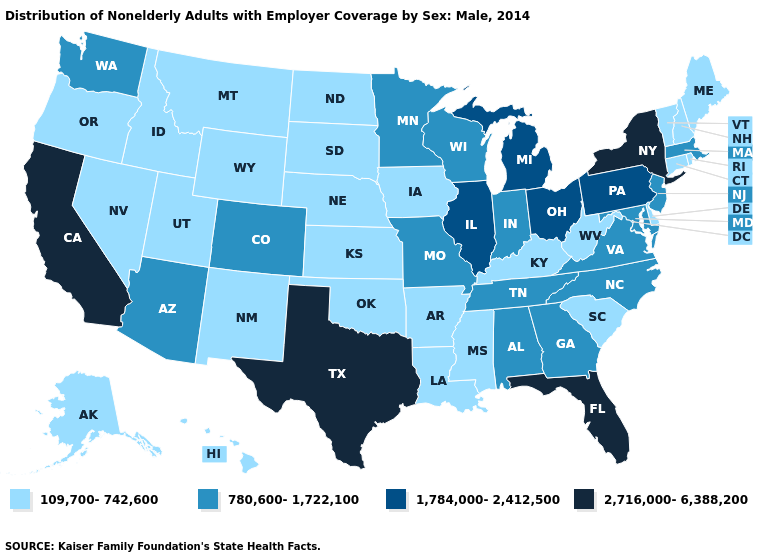What is the highest value in the MidWest ?
Be succinct. 1,784,000-2,412,500. Does the map have missing data?
Quick response, please. No. Does Virginia have a higher value than South Dakota?
Be succinct. Yes. Name the states that have a value in the range 1,784,000-2,412,500?
Answer briefly. Illinois, Michigan, Ohio, Pennsylvania. Among the states that border Ohio , which have the highest value?
Give a very brief answer. Michigan, Pennsylvania. What is the highest value in the MidWest ?
Short answer required. 1,784,000-2,412,500. Among the states that border Vermont , does New York have the lowest value?
Give a very brief answer. No. What is the lowest value in the USA?
Write a very short answer. 109,700-742,600. Does the map have missing data?
Quick response, please. No. Does the map have missing data?
Write a very short answer. No. What is the value of Oklahoma?
Short answer required. 109,700-742,600. Among the states that border Mississippi , which have the highest value?
Keep it brief. Alabama, Tennessee. Name the states that have a value in the range 1,784,000-2,412,500?
Concise answer only. Illinois, Michigan, Ohio, Pennsylvania. Name the states that have a value in the range 1,784,000-2,412,500?
Concise answer only. Illinois, Michigan, Ohio, Pennsylvania. Name the states that have a value in the range 2,716,000-6,388,200?
Keep it brief. California, Florida, New York, Texas. 